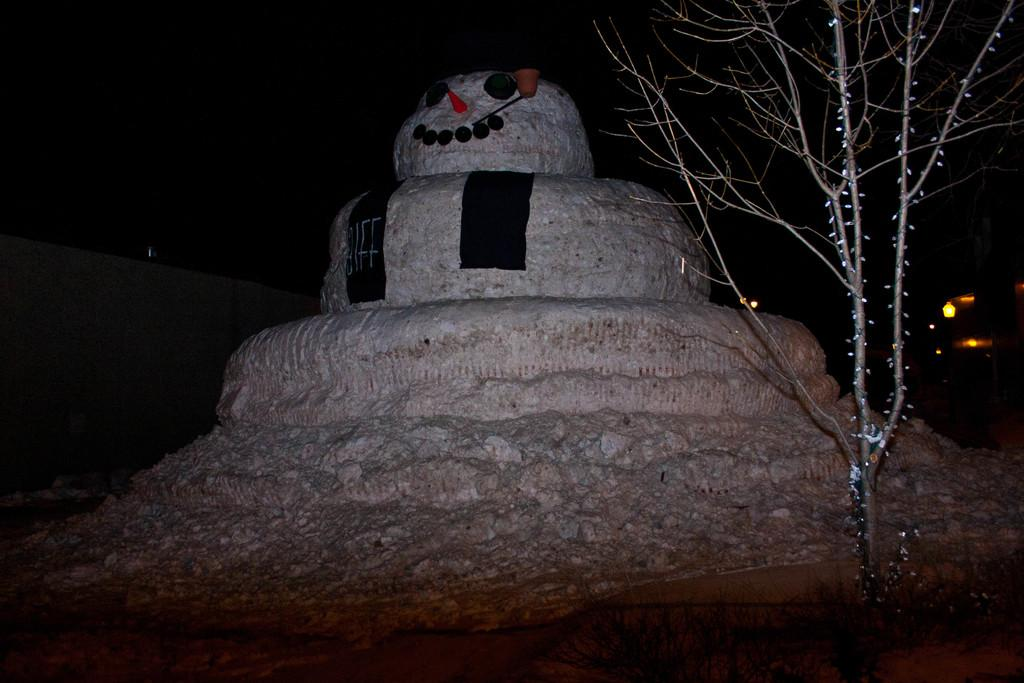What is the main subject of the image? There is a snowman in the image. What else can be seen in the image besides the snowman? There is a tree and lights in the image. How would you describe the sky in the image? The sky is dark in the image. What type of apple is hanging from the tree in the image? There is no apple present in the image; it features a snowman, a tree, and lights. Can you see any feathers on the snowman in the image? There are no feathers present on the snowman in the image. 